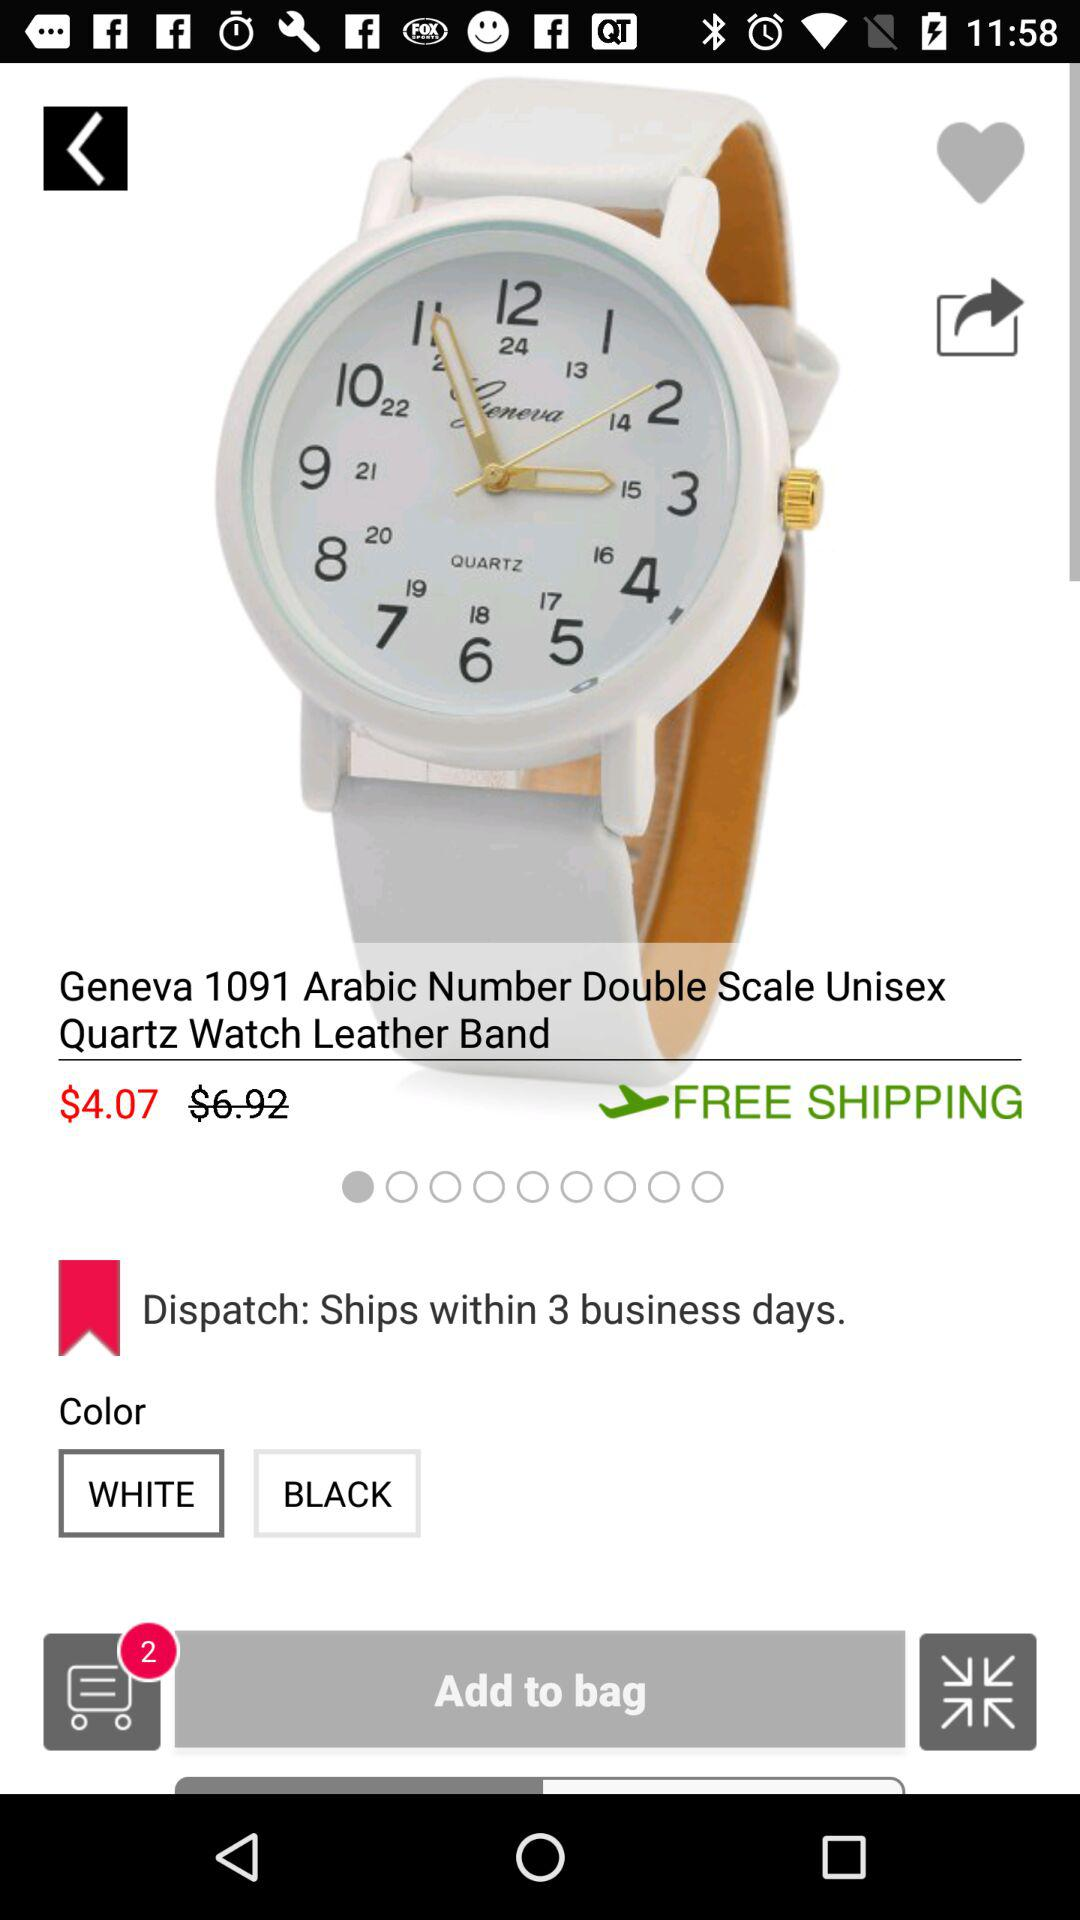What are the color options? The color options are "WHITE" and "BLACK". 